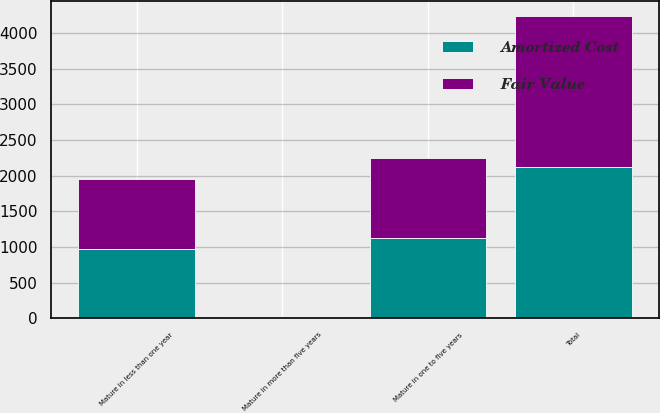Convert chart to OTSL. <chart><loc_0><loc_0><loc_500><loc_500><stacked_bar_chart><ecel><fcel>Mature in less than one year<fcel>Mature in one to five years<fcel>Mature in more than five years<fcel>Total<nl><fcel>Fair Value<fcel>976.2<fcel>1122.3<fcel>20<fcel>2118.5<nl><fcel>Amortized Cost<fcel>976.7<fcel>1126.1<fcel>16.4<fcel>2119.2<nl></chart> 